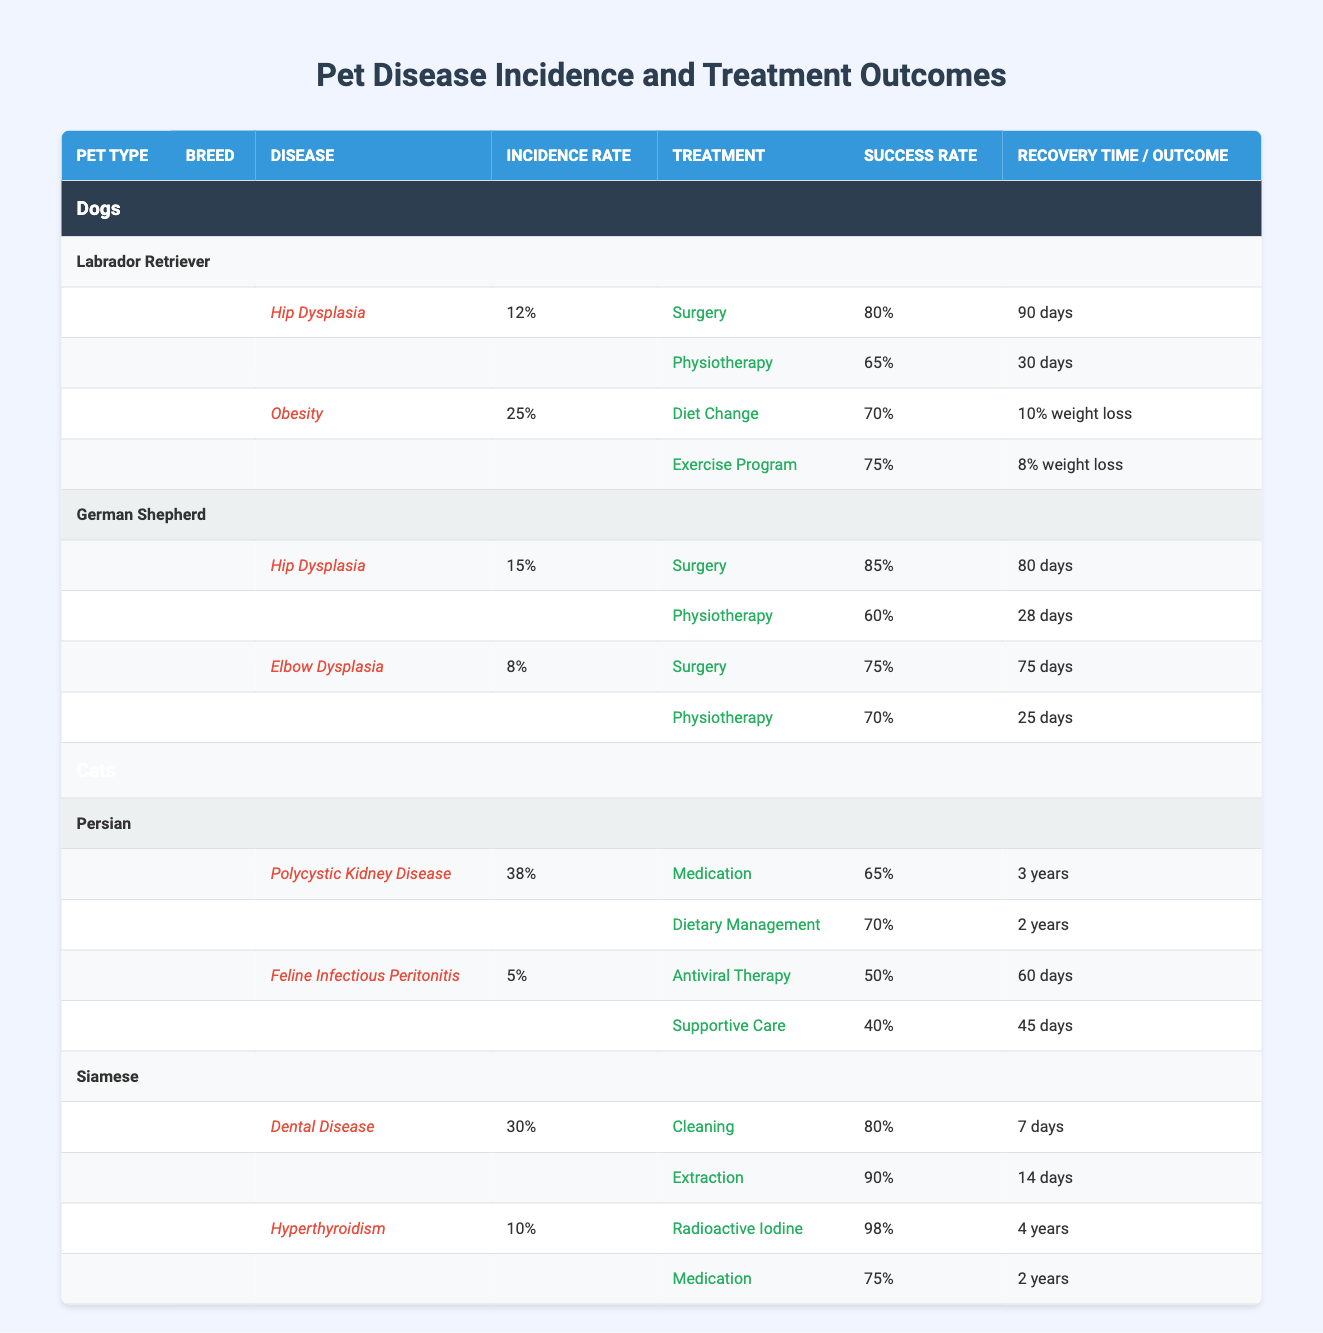What is the incidence rate of hip dysplasia in Labrador Retrievers? The incidence rate for hip dysplasia in Labrador Retrievers is listed in the table under the Labrador breed and the hip dysplasia disease row, showing a percentage of 12.
Answer: 12% Which treatment method for obesity in Labrador Retrievers has a higher success rate: diet change or exercise program? The table shows the success rate for two treatment methods for obesity in Labrador Retrievers. The diet change method has a success rate of 70%, while the exercise program has a greater success rate of 75%.
Answer: Exercise program True or False: The success rate of surgery for hip dysplasia in German Shepherds is greater than 80%. The table lists the success rate of surgery for hip dysplasia in German Shepherds as 85%. Since 85% is greater than 80%, the statement is True.
Answer: True What is the average recovery time in days for surgery and physiotherapy treatments combined for hip dysplasia in German Shepherds? The table shows that the recovery time for surgery is 80 days and for physiotherapy is 28 days. To find the average, add both recovery times (80 + 28 = 108) and divide by 2, yielding an average of 54 days.
Answer: 54 days Which breed has the highest percentage for any disease listed, and what is that percentage? The Persian cat has the highest incidence rate, with 38% for polycystic kidney disease. This is identified by comparing the percentages of each disease across all pet types and breeds in the table.
Answer: Persian, 38% 